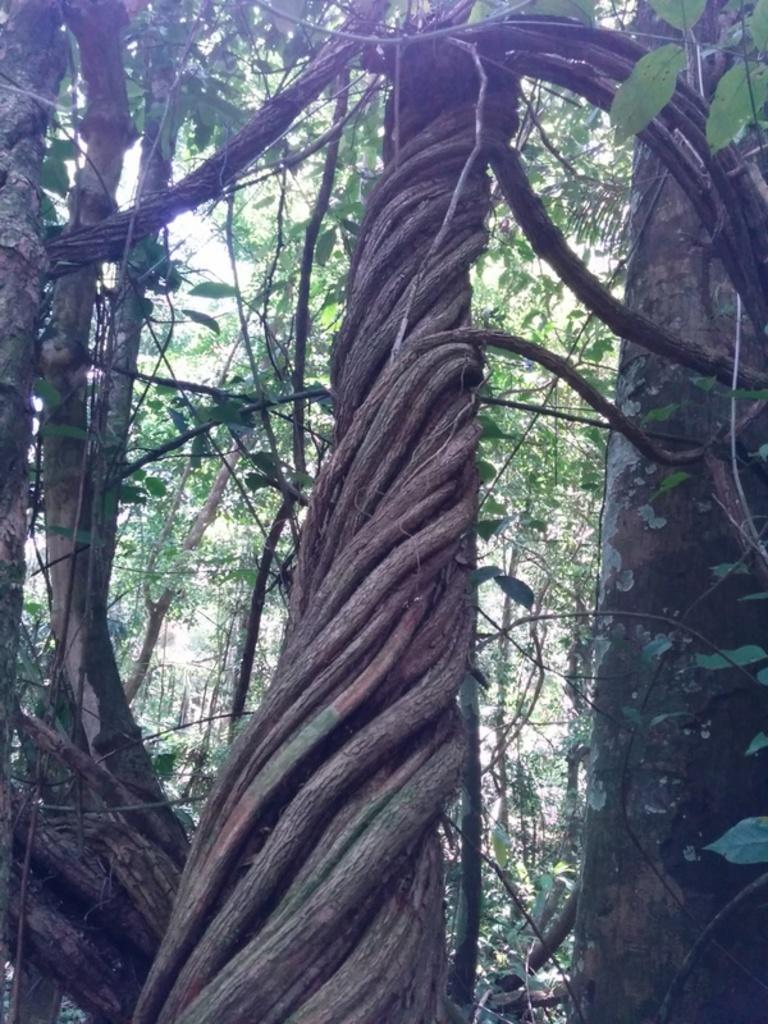What type of vegetation can be seen in the image? There are trees in the image. What is present on the trees in the image? There are leaves on the trees in the image. What type of lace can be seen on the mountain in the image? There is no mountain or lace present in the image; it only features trees with leaves. 